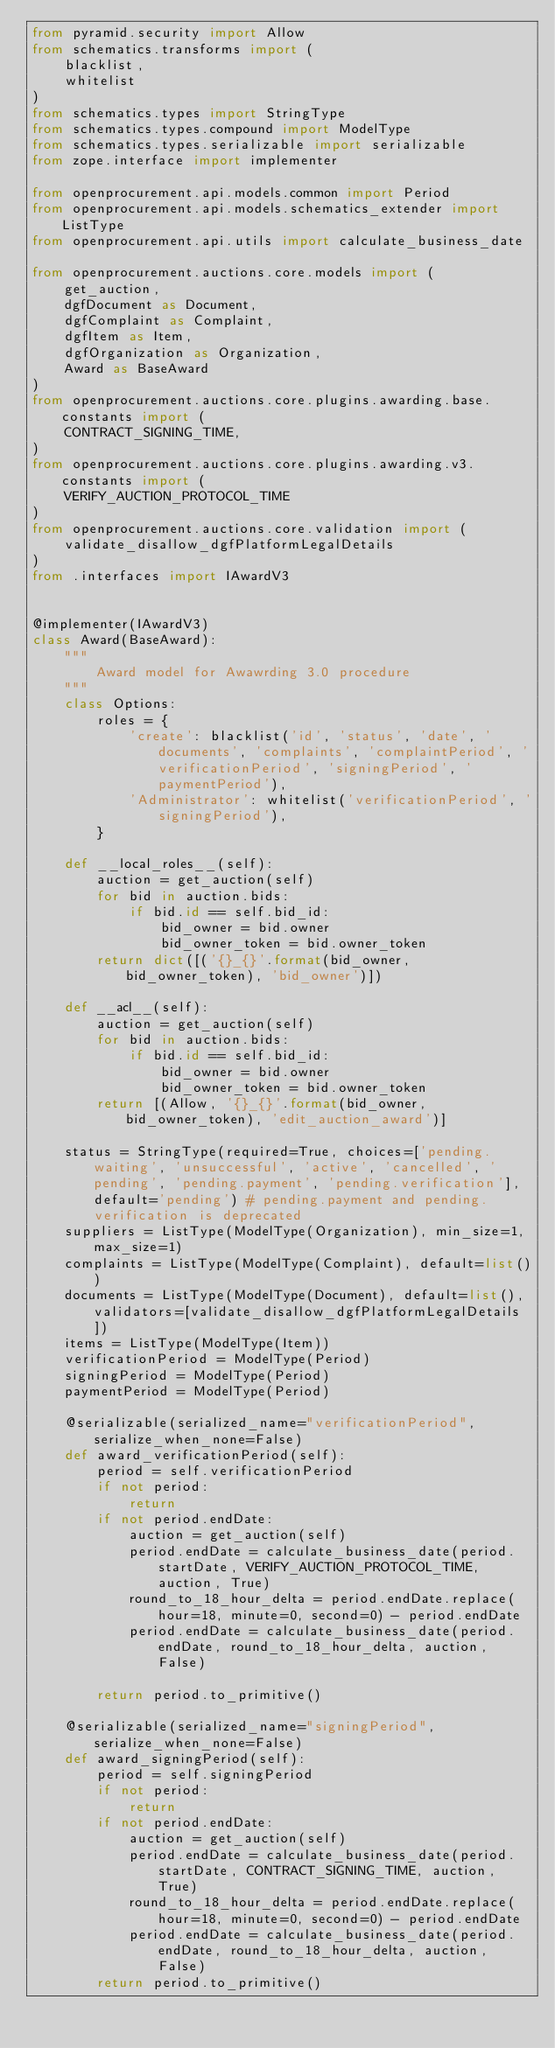<code> <loc_0><loc_0><loc_500><loc_500><_Python_>from pyramid.security import Allow
from schematics.transforms import (
    blacklist,
    whitelist
)
from schematics.types import StringType
from schematics.types.compound import ModelType
from schematics.types.serializable import serializable
from zope.interface import implementer

from openprocurement.api.models.common import Period
from openprocurement.api.models.schematics_extender import ListType
from openprocurement.api.utils import calculate_business_date

from openprocurement.auctions.core.models import (
    get_auction,
    dgfDocument as Document,
    dgfComplaint as Complaint,
    dgfItem as Item,
    dgfOrganization as Organization,
    Award as BaseAward
)
from openprocurement.auctions.core.plugins.awarding.base.constants import (
    CONTRACT_SIGNING_TIME,
)
from openprocurement.auctions.core.plugins.awarding.v3.constants import (
    VERIFY_AUCTION_PROTOCOL_TIME
)
from openprocurement.auctions.core.validation import (
    validate_disallow_dgfPlatformLegalDetails
)
from .interfaces import IAwardV3


@implementer(IAwardV3)
class Award(BaseAward):
    """
        Award model for Awawrding 3.0 procedure
    """
    class Options:
        roles = {
            'create': blacklist('id', 'status', 'date', 'documents', 'complaints', 'complaintPeriod', 'verificationPeriod', 'signingPeriod', 'paymentPeriod'),
            'Administrator': whitelist('verificationPeriod', 'signingPeriod'),
        }

    def __local_roles__(self):
        auction = get_auction(self)
        for bid in auction.bids:
            if bid.id == self.bid_id:
                bid_owner = bid.owner
                bid_owner_token = bid.owner_token
        return dict([('{}_{}'.format(bid_owner, bid_owner_token), 'bid_owner')])

    def __acl__(self):
        auction = get_auction(self)
        for bid in auction.bids:
            if bid.id == self.bid_id:
                bid_owner = bid.owner
                bid_owner_token = bid.owner_token
        return [(Allow, '{}_{}'.format(bid_owner, bid_owner_token), 'edit_auction_award')]

    status = StringType(required=True, choices=['pending.waiting', 'unsuccessful', 'active', 'cancelled', 'pending', 'pending.payment', 'pending.verification'], default='pending') # pending.payment and pending.verification is deprecated
    suppliers = ListType(ModelType(Organization), min_size=1, max_size=1)
    complaints = ListType(ModelType(Complaint), default=list())
    documents = ListType(ModelType(Document), default=list(), validators=[validate_disallow_dgfPlatformLegalDetails])
    items = ListType(ModelType(Item))
    verificationPeriod = ModelType(Period)
    signingPeriod = ModelType(Period)
    paymentPeriod = ModelType(Period)

    @serializable(serialized_name="verificationPeriod", serialize_when_none=False)
    def award_verificationPeriod(self):
        period = self.verificationPeriod
        if not period:
            return
        if not period.endDate:
            auction = get_auction(self)
            period.endDate = calculate_business_date(period.startDate, VERIFY_AUCTION_PROTOCOL_TIME, auction, True)
            round_to_18_hour_delta = period.endDate.replace(hour=18, minute=0, second=0) - period.endDate
            period.endDate = calculate_business_date(period.endDate, round_to_18_hour_delta, auction, False)

        return period.to_primitive()

    @serializable(serialized_name="signingPeriod", serialize_when_none=False)
    def award_signingPeriod(self):
        period = self.signingPeriod
        if not period:
            return
        if not period.endDate:
            auction = get_auction(self)
            period.endDate = calculate_business_date(period.startDate, CONTRACT_SIGNING_TIME, auction, True)
            round_to_18_hour_delta = period.endDate.replace(hour=18, minute=0, second=0) - period.endDate
            period.endDate = calculate_business_date(period.endDate, round_to_18_hour_delta, auction, False)
        return period.to_primitive()
</code> 